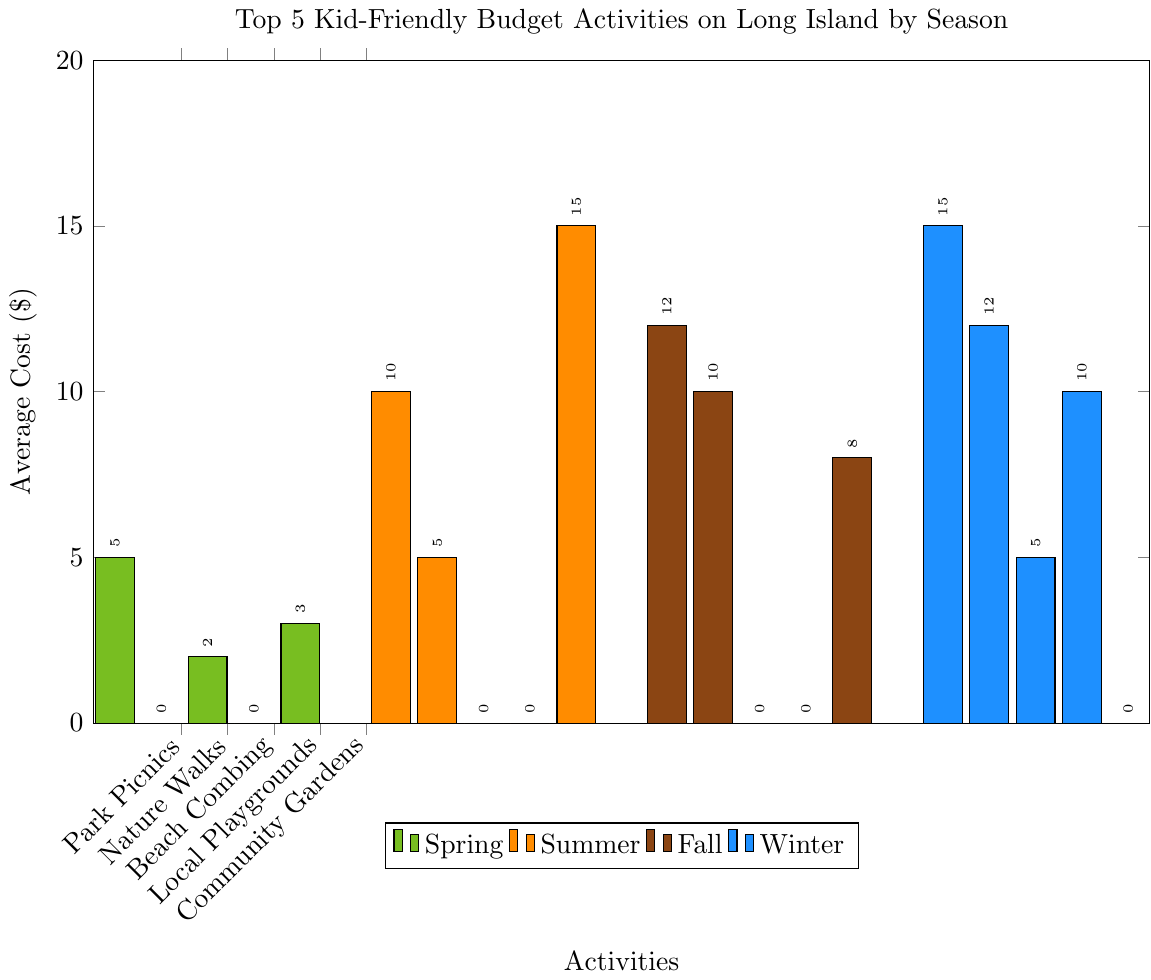what is the most budget-friendly activity in summer? The most budget-friendly activity can be identified by finding the activity with the lowest average cost in the summer category. According to the figure, the lowest cost is represented by the splash pads or library programs with a cost of $0.
Answer: splash pads, library programs Which season has the activity with the highest average cost overall? To find this, I will identify the activity with the highest bar in all seasons. The tallest bar appears in the winter season for indoor museums and in the summer season for backyard camping, both costing $15. Therefore, both seasons, summer and winter, have activities with the highest average cost.
Answer: summer, winter What's the difference in average costs between the most expensive winter activity and the most expensive spring activity? The most expensive winter activity (indoor museums) costs $15, while the most expensive spring activity (park picnics) costs $5. The difference is $15 - $5 = $10.
Answer: $10 What is the total number of activities in spring that have an average cost of $0? The number of such activities can be counted by looking at the bars for the spring activities which have a height equal to zero. According to the figure, Nature Walks and Local Playgrounds have an average cost of $0. So, there are 2 activities.
Answer: 2 Compare the popularity score of beach Days in summer to beach combing in spring. Which is more popular? From the provided data, the popularity score for Beach Days in summer is 10, and the popularity score for Beach Combing in spring is 7. Since 10 > 7, Beach Days in summer is more popular.
Answer: Beach Days in summer What's the sum of the average costs for all summer activities? Adding the heights of all the bars in the summer season: Beach Days ($10) + Outdoor Movies ($5) + Splash Pads ($0) + Library Programs ($0) + Backyard Camping ($15) = $30.
Answer: $30 Which activity in fall has an average cost equal to Ice Skating in winter? Ice Skating in winter costs $12. By comparing the average costs in fall, Apple Picking has the same average cost of $12.
Answer: Apple Picking What's the ratio of the average cost of community gardens to indoor museums? The average cost of community gardens in spring is $3, and the average cost of indoor museums in winter is $15. The ratio is calculated as 3/15 = 1:5.
Answer: 1:5 